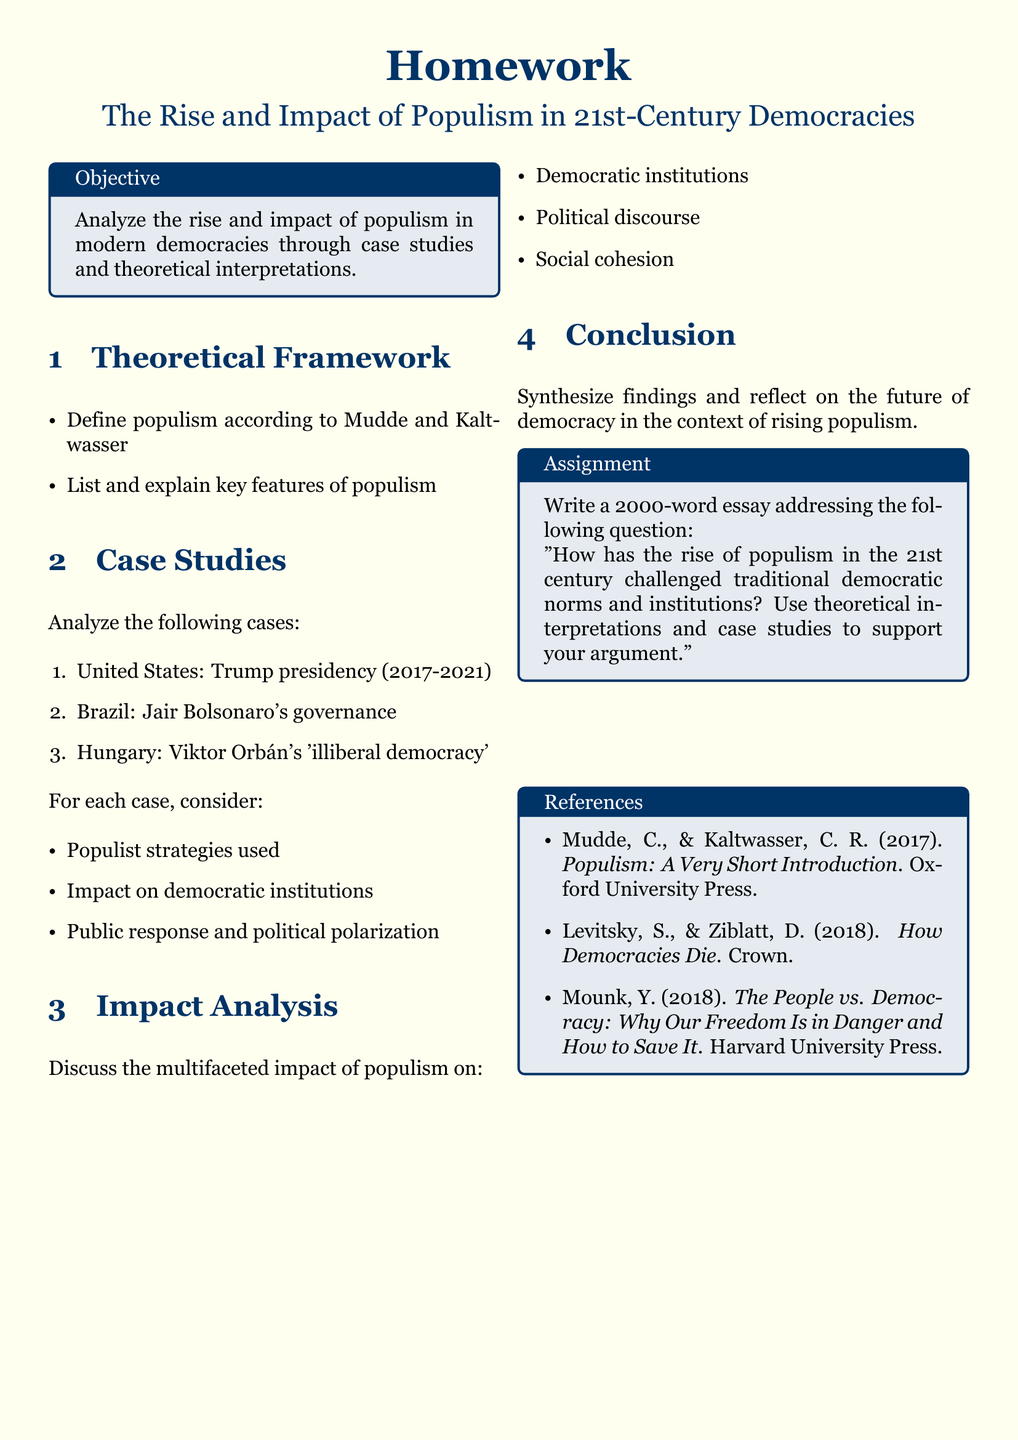What is the objective of the homework? The objective is to analyze the rise and impact of populism in modern democracies through case studies and theoretical interpretations.
Answer: Analyze the rise and impact of populism in modern democracies through case studies and theoretical interpretations Who are the authors referenced for the definition of populism? The document mentions two authors, Mudde and Kaltwasser, who define populism.
Answer: Mudde and Kaltwasser What are the three case studies mentioned in the document? The document lists three case studies: the United States, Brazil, and Hungary.
Answer: United States, Brazil, Hungary How many words should the essay be? The assignment specifies the essay length as 2000 words.
Answer: 2000 What type of democracy is Viktor Orbán associated with? The document describes Viktor Orbán's governance as 'illiberal democracy'.
Answer: Illiberal democracy What are the three aspects to discuss in the impact analysis section? The impact analysis should cover democratic institutions, political discourse, and social cohesion.
Answer: Democratic institutions, political discourse, social cohesion Who published the book "How Democracies Die"? The book "How Democracies Die" was published by two authors: Levitsky and Ziblatt.
Answer: Levitsky and Ziblatt What is the main question to address in the essay? The essay should answer how the rise of populism has challenged traditional democratic norms and institutions.
Answer: How has the rise of populism in the 21st century challenged traditional democratic norms and institutions? 